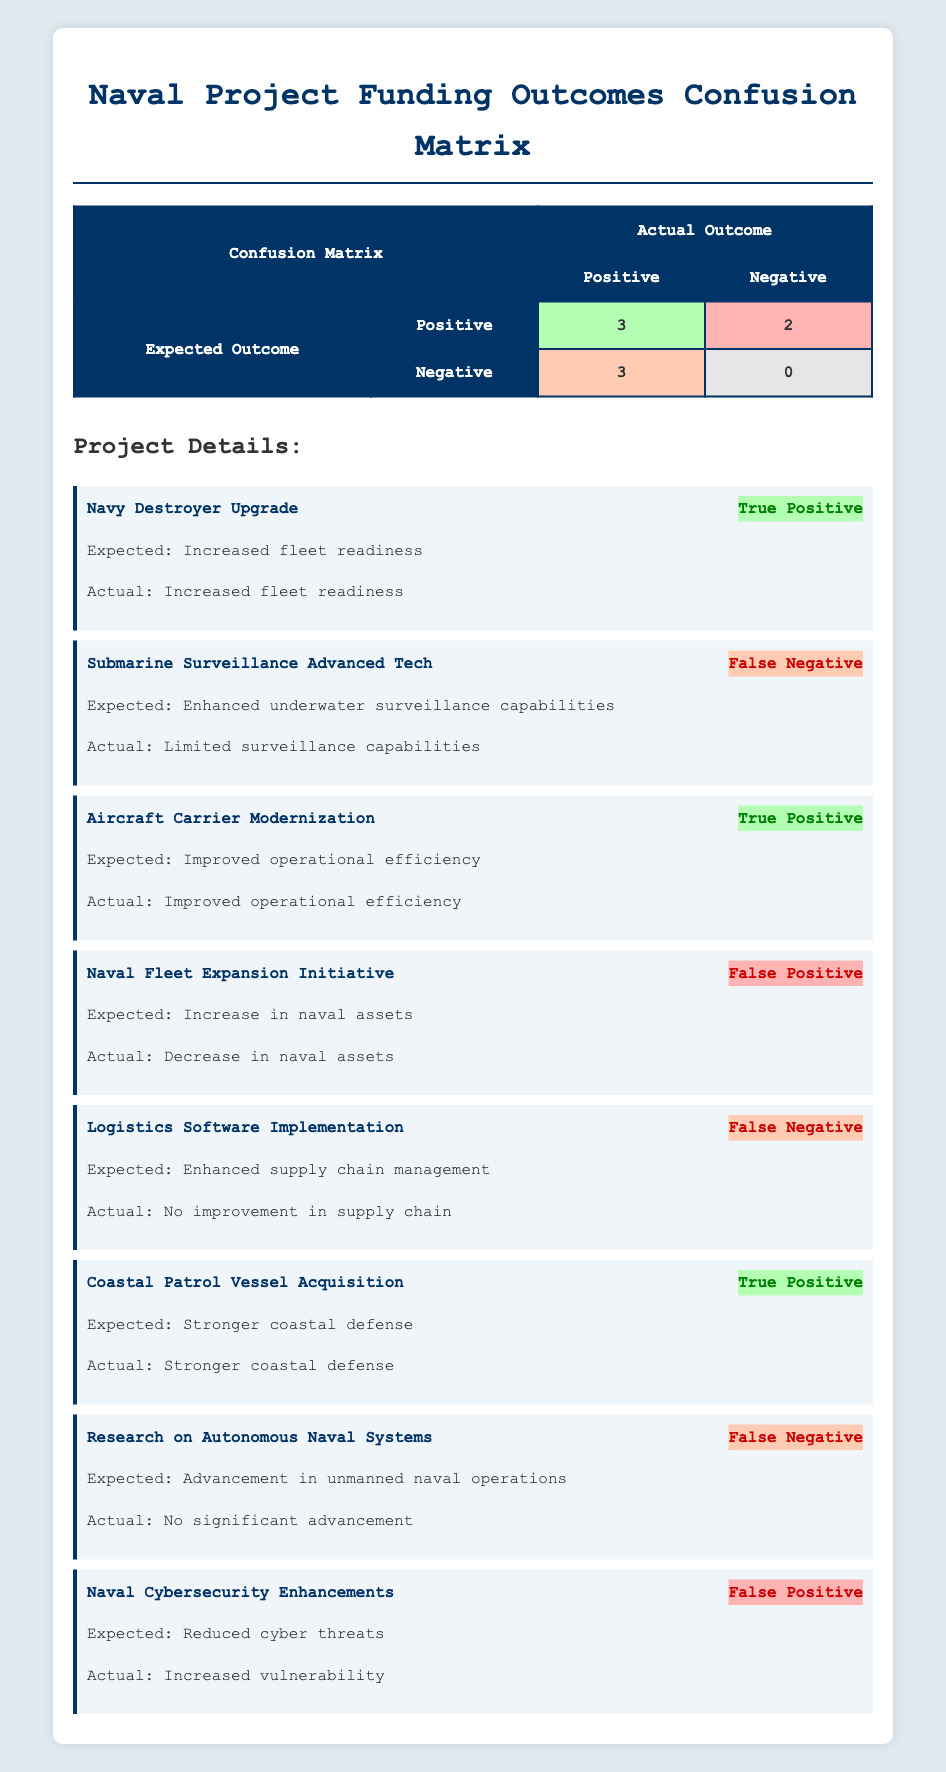What is the total number of True Positives? There are 3 projects categorized as True Positives in the table: the Navy Destroyer Upgrade, Aircraft Carrier Modernization, and Coastal Patrol Vessel Acquisition. Therefore, the total number is simply the count of these projects, which is 3.
Answer: 3 How many projects resulted in a False Negative outcome? The table shows 3 projects classified as False Negatives: Submarine Surveillance Advanced Tech, Logistics Software Implementation, and Research on Autonomous Naval Systems. Counting these gives a total of 3 projects.
Answer: 3 Is there any project in the table that resulted in a True Negative? According to the table, there are no projects that resulted in a True Negative outcome. The column for True Negative shows a value of 0, indicating that no project achieved the expected outcome when the actual outcome was negative.
Answer: No What is the difference in the number of projects classified as False Positives and True Positives? From the table, there are 2 False Positive projects (Naval Fleet Expansion Initiative and Naval Cybersecurity Enhancements) and 3 True Positive projects. The difference is calculated as 3 (True Positives) - 2 (False Positives) = 1.
Answer: 1 What is the percentage of projects that were successful (True Positives) out of the total projects analyzed? There are a total of 8 projects listed in the table. Among these, 3 are True Positives. To find the percentage, we calculate (3 True Positives / 8 Total Projects) * 100 = 37.5%.
Answer: 37.5% List all the project names that resulted in False Positive outcomes. The projects that resulted in False Positive outcomes are: Naval Fleet Expansion Initiative and Naval Cybersecurity Enhancements, as indicated under the False Positive category in the table.
Answer: Naval Fleet Expansion Initiative, Naval Cybersecurity Enhancements How many projects are there with an expected outcome of enhanced capabilities that were successful? The projects expected to enhance capabilities that were successful (True Positive) are: Navy Destroyer Upgrade (Increased fleet readiness) and Aircraft Carrier Modernization (Improved operational efficiency). Hence, there are 2 projects fulfilling this criterion.
Answer: 2 Which project had the highest discrepancy between expected and actual outcomes? The Naval Fleet Expansion Initiative had the highest discrepancy as it expected an increase in naval assets but resulted in a decrease. This difference represents a total failure of expected outcome versus actual outcome.
Answer: Naval Fleet Expansion Initiative 